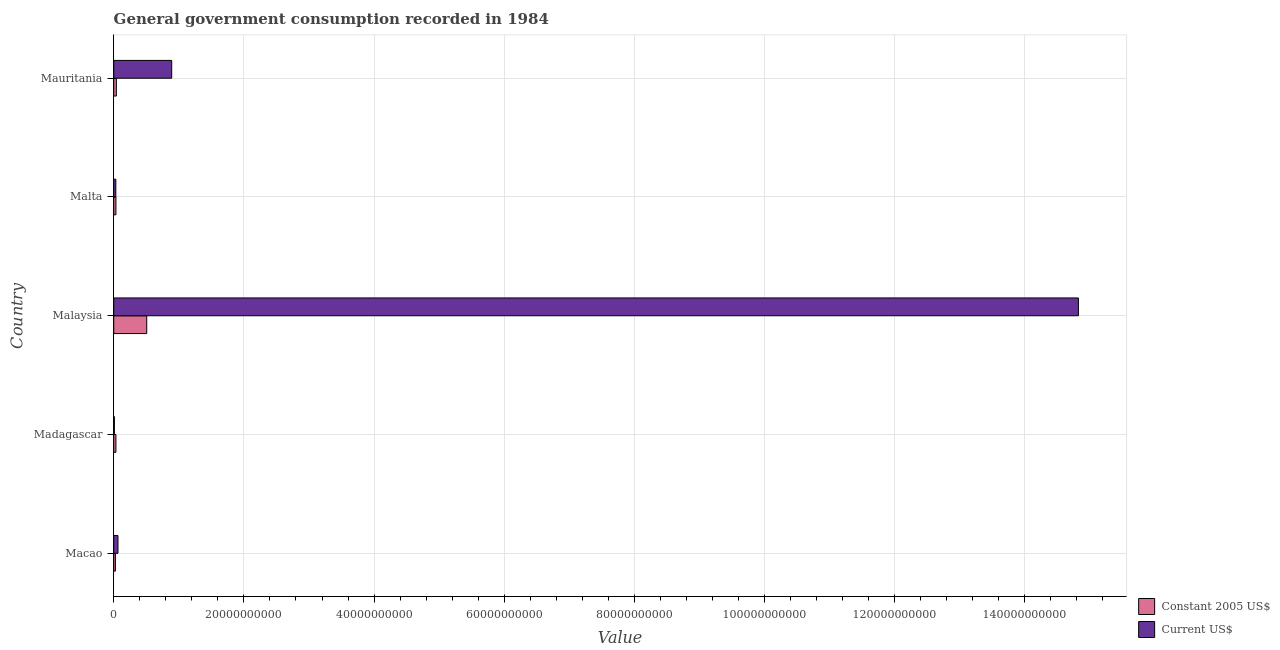How many groups of bars are there?
Your answer should be very brief. 5. Are the number of bars per tick equal to the number of legend labels?
Offer a terse response. Yes. How many bars are there on the 1st tick from the bottom?
Ensure brevity in your answer.  2. What is the label of the 5th group of bars from the top?
Your answer should be very brief. Macao. In how many cases, is the number of bars for a given country not equal to the number of legend labels?
Your response must be concise. 0. What is the value consumed in current us$ in Madagascar?
Offer a very short reply. 9.67e+07. Across all countries, what is the maximum value consumed in current us$?
Provide a short and direct response. 1.48e+11. Across all countries, what is the minimum value consumed in constant 2005 us$?
Ensure brevity in your answer.  2.57e+08. In which country was the value consumed in current us$ maximum?
Provide a succinct answer. Malaysia. In which country was the value consumed in constant 2005 us$ minimum?
Give a very brief answer. Macao. What is the total value consumed in current us$ in the graph?
Keep it short and to the point. 1.58e+11. What is the difference between the value consumed in constant 2005 us$ in Macao and that in Malaysia?
Your answer should be very brief. -4.81e+09. What is the difference between the value consumed in constant 2005 us$ in Madagascar and the value consumed in current us$ in Macao?
Offer a very short reply. -3.15e+08. What is the average value consumed in current us$ per country?
Keep it short and to the point. 3.16e+1. What is the difference between the value consumed in constant 2005 us$ and value consumed in current us$ in Macao?
Offer a terse response. -3.94e+08. In how many countries, is the value consumed in constant 2005 us$ greater than 8000000000 ?
Provide a short and direct response. 0. What is the ratio of the value consumed in current us$ in Malaysia to that in Malta?
Your response must be concise. 462.77. Is the difference between the value consumed in current us$ in Malaysia and Malta greater than the difference between the value consumed in constant 2005 us$ in Malaysia and Malta?
Offer a terse response. Yes. What is the difference between the highest and the second highest value consumed in constant 2005 us$?
Your answer should be very brief. 4.67e+09. What is the difference between the highest and the lowest value consumed in current us$?
Make the answer very short. 1.48e+11. Is the sum of the value consumed in constant 2005 us$ in Macao and Malaysia greater than the maximum value consumed in current us$ across all countries?
Your response must be concise. No. What does the 1st bar from the top in Malaysia represents?
Offer a terse response. Current US$. What does the 1st bar from the bottom in Malaysia represents?
Make the answer very short. Constant 2005 US$. How many bars are there?
Offer a terse response. 10. How many countries are there in the graph?
Your answer should be very brief. 5. What is the difference between two consecutive major ticks on the X-axis?
Your answer should be very brief. 2.00e+1. Are the values on the major ticks of X-axis written in scientific E-notation?
Offer a very short reply. No. Does the graph contain grids?
Provide a succinct answer. Yes. Where does the legend appear in the graph?
Your answer should be very brief. Bottom right. What is the title of the graph?
Make the answer very short. General government consumption recorded in 1984. Does "Time to export" appear as one of the legend labels in the graph?
Keep it short and to the point. No. What is the label or title of the X-axis?
Your answer should be very brief. Value. What is the label or title of the Y-axis?
Keep it short and to the point. Country. What is the Value in Constant 2005 US$ in Macao?
Offer a terse response. 2.57e+08. What is the Value in Current US$ in Macao?
Offer a very short reply. 6.51e+08. What is the Value in Constant 2005 US$ in Madagascar?
Your answer should be very brief. 3.36e+08. What is the Value in Current US$ in Madagascar?
Your response must be concise. 9.67e+07. What is the Value of Constant 2005 US$ in Malaysia?
Your response must be concise. 5.07e+09. What is the Value in Current US$ in Malaysia?
Keep it short and to the point. 1.48e+11. What is the Value of Constant 2005 US$ in Malta?
Provide a succinct answer. 3.38e+08. What is the Value in Current US$ in Malta?
Provide a succinct answer. 3.20e+08. What is the Value of Constant 2005 US$ in Mauritania?
Provide a short and direct response. 4.01e+08. What is the Value in Current US$ in Mauritania?
Provide a short and direct response. 8.91e+09. Across all countries, what is the maximum Value in Constant 2005 US$?
Provide a succinct answer. 5.07e+09. Across all countries, what is the maximum Value of Current US$?
Your answer should be very brief. 1.48e+11. Across all countries, what is the minimum Value of Constant 2005 US$?
Make the answer very short. 2.57e+08. Across all countries, what is the minimum Value in Current US$?
Provide a short and direct response. 9.67e+07. What is the total Value of Constant 2005 US$ in the graph?
Offer a terse response. 6.40e+09. What is the total Value in Current US$ in the graph?
Offer a very short reply. 1.58e+11. What is the difference between the Value in Constant 2005 US$ in Macao and that in Madagascar?
Offer a terse response. -7.90e+07. What is the difference between the Value in Current US$ in Macao and that in Madagascar?
Offer a very short reply. 5.54e+08. What is the difference between the Value of Constant 2005 US$ in Macao and that in Malaysia?
Ensure brevity in your answer.  -4.81e+09. What is the difference between the Value of Current US$ in Macao and that in Malaysia?
Your answer should be very brief. -1.48e+11. What is the difference between the Value in Constant 2005 US$ in Macao and that in Malta?
Ensure brevity in your answer.  -8.12e+07. What is the difference between the Value in Current US$ in Macao and that in Malta?
Provide a short and direct response. 3.31e+08. What is the difference between the Value of Constant 2005 US$ in Macao and that in Mauritania?
Your answer should be compact. -1.45e+08. What is the difference between the Value of Current US$ in Macao and that in Mauritania?
Make the answer very short. -8.26e+09. What is the difference between the Value of Constant 2005 US$ in Madagascar and that in Malaysia?
Offer a very short reply. -4.73e+09. What is the difference between the Value of Current US$ in Madagascar and that in Malaysia?
Your answer should be very brief. -1.48e+11. What is the difference between the Value in Constant 2005 US$ in Madagascar and that in Malta?
Ensure brevity in your answer.  -2.18e+06. What is the difference between the Value of Current US$ in Madagascar and that in Malta?
Give a very brief answer. -2.24e+08. What is the difference between the Value of Constant 2005 US$ in Madagascar and that in Mauritania?
Your answer should be compact. -6.56e+07. What is the difference between the Value in Current US$ in Madagascar and that in Mauritania?
Your answer should be very brief. -8.81e+09. What is the difference between the Value in Constant 2005 US$ in Malaysia and that in Malta?
Offer a very short reply. 4.73e+09. What is the difference between the Value in Current US$ in Malaysia and that in Malta?
Ensure brevity in your answer.  1.48e+11. What is the difference between the Value of Constant 2005 US$ in Malaysia and that in Mauritania?
Provide a short and direct response. 4.67e+09. What is the difference between the Value of Current US$ in Malaysia and that in Mauritania?
Provide a succinct answer. 1.39e+11. What is the difference between the Value in Constant 2005 US$ in Malta and that in Mauritania?
Your answer should be very brief. -6.35e+07. What is the difference between the Value in Current US$ in Malta and that in Mauritania?
Provide a succinct answer. -8.59e+09. What is the difference between the Value of Constant 2005 US$ in Macao and the Value of Current US$ in Madagascar?
Your answer should be compact. 1.60e+08. What is the difference between the Value of Constant 2005 US$ in Macao and the Value of Current US$ in Malaysia?
Your answer should be compact. -1.48e+11. What is the difference between the Value in Constant 2005 US$ in Macao and the Value in Current US$ in Malta?
Ensure brevity in your answer.  -6.36e+07. What is the difference between the Value in Constant 2005 US$ in Macao and the Value in Current US$ in Mauritania?
Keep it short and to the point. -8.65e+09. What is the difference between the Value in Constant 2005 US$ in Madagascar and the Value in Current US$ in Malaysia?
Provide a short and direct response. -1.48e+11. What is the difference between the Value in Constant 2005 US$ in Madagascar and the Value in Current US$ in Malta?
Your answer should be compact. 1.55e+07. What is the difference between the Value of Constant 2005 US$ in Madagascar and the Value of Current US$ in Mauritania?
Your response must be concise. -8.57e+09. What is the difference between the Value of Constant 2005 US$ in Malaysia and the Value of Current US$ in Malta?
Make the answer very short. 4.75e+09. What is the difference between the Value of Constant 2005 US$ in Malaysia and the Value of Current US$ in Mauritania?
Your answer should be very brief. -3.84e+09. What is the difference between the Value of Constant 2005 US$ in Malta and the Value of Current US$ in Mauritania?
Provide a short and direct response. -8.57e+09. What is the average Value of Constant 2005 US$ per country?
Keep it short and to the point. 1.28e+09. What is the average Value in Current US$ per country?
Provide a short and direct response. 3.16e+1. What is the difference between the Value in Constant 2005 US$ and Value in Current US$ in Macao?
Your answer should be compact. -3.94e+08. What is the difference between the Value of Constant 2005 US$ and Value of Current US$ in Madagascar?
Your answer should be compact. 2.39e+08. What is the difference between the Value of Constant 2005 US$ and Value of Current US$ in Malaysia?
Keep it short and to the point. -1.43e+11. What is the difference between the Value in Constant 2005 US$ and Value in Current US$ in Malta?
Provide a succinct answer. 1.76e+07. What is the difference between the Value of Constant 2005 US$ and Value of Current US$ in Mauritania?
Your answer should be compact. -8.51e+09. What is the ratio of the Value of Constant 2005 US$ in Macao to that in Madagascar?
Offer a terse response. 0.76. What is the ratio of the Value in Current US$ in Macao to that in Madagascar?
Offer a very short reply. 6.73. What is the ratio of the Value of Constant 2005 US$ in Macao to that in Malaysia?
Make the answer very short. 0.05. What is the ratio of the Value in Current US$ in Macao to that in Malaysia?
Give a very brief answer. 0. What is the ratio of the Value in Constant 2005 US$ in Macao to that in Malta?
Keep it short and to the point. 0.76. What is the ratio of the Value in Current US$ in Macao to that in Malta?
Make the answer very short. 2.03. What is the ratio of the Value of Constant 2005 US$ in Macao to that in Mauritania?
Your answer should be very brief. 0.64. What is the ratio of the Value in Current US$ in Macao to that in Mauritania?
Give a very brief answer. 0.07. What is the ratio of the Value of Constant 2005 US$ in Madagascar to that in Malaysia?
Your response must be concise. 0.07. What is the ratio of the Value of Current US$ in Madagascar to that in Malaysia?
Your answer should be very brief. 0. What is the ratio of the Value of Constant 2005 US$ in Madagascar to that in Malta?
Offer a terse response. 0.99. What is the ratio of the Value in Current US$ in Madagascar to that in Malta?
Keep it short and to the point. 0.3. What is the ratio of the Value in Constant 2005 US$ in Madagascar to that in Mauritania?
Your answer should be very brief. 0.84. What is the ratio of the Value in Current US$ in Madagascar to that in Mauritania?
Your answer should be very brief. 0.01. What is the ratio of the Value of Constant 2005 US$ in Malaysia to that in Malta?
Give a very brief answer. 15. What is the ratio of the Value of Current US$ in Malaysia to that in Malta?
Give a very brief answer. 462.77. What is the ratio of the Value of Constant 2005 US$ in Malaysia to that in Mauritania?
Provide a succinct answer. 12.63. What is the ratio of the Value of Current US$ in Malaysia to that in Mauritania?
Your response must be concise. 16.64. What is the ratio of the Value of Constant 2005 US$ in Malta to that in Mauritania?
Give a very brief answer. 0.84. What is the ratio of the Value of Current US$ in Malta to that in Mauritania?
Ensure brevity in your answer.  0.04. What is the difference between the highest and the second highest Value in Constant 2005 US$?
Keep it short and to the point. 4.67e+09. What is the difference between the highest and the second highest Value of Current US$?
Offer a terse response. 1.39e+11. What is the difference between the highest and the lowest Value of Constant 2005 US$?
Your answer should be very brief. 4.81e+09. What is the difference between the highest and the lowest Value in Current US$?
Your answer should be compact. 1.48e+11. 